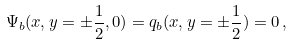<formula> <loc_0><loc_0><loc_500><loc_500>\Psi _ { b } ( x , y = \pm \frac { 1 } { 2 } , 0 ) = q _ { b } ( x , y = \pm \frac { 1 } { 2 } ) = 0 \, ,</formula> 